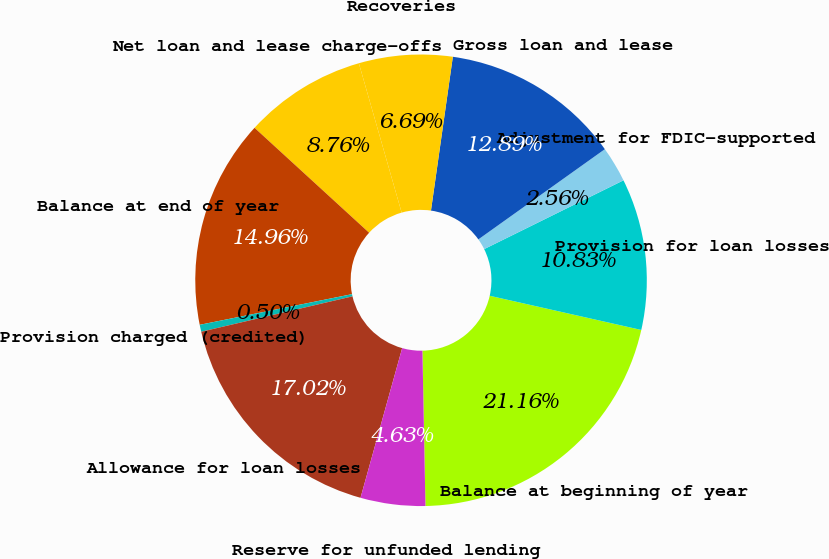Convert chart. <chart><loc_0><loc_0><loc_500><loc_500><pie_chart><fcel>Balance at beginning of year<fcel>Provision for loan losses<fcel>Adjustment for FDIC-supported<fcel>Gross loan and lease<fcel>Recoveries<fcel>Net loan and lease charge-offs<fcel>Balance at end of year<fcel>Provision charged (credited)<fcel>Allowance for loan losses<fcel>Reserve for unfunded lending<nl><fcel>21.16%<fcel>10.83%<fcel>2.56%<fcel>12.89%<fcel>6.69%<fcel>8.76%<fcel>14.96%<fcel>0.5%<fcel>17.02%<fcel>4.63%<nl></chart> 